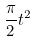<formula> <loc_0><loc_0><loc_500><loc_500>\frac { \pi } { 2 } t ^ { 2 }</formula> 